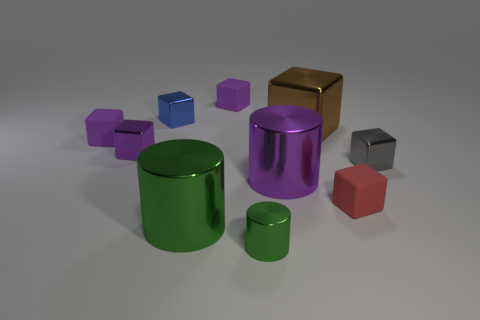Subtract all yellow spheres. How many purple blocks are left? 3 Subtract all tiny metallic cubes. How many cubes are left? 4 Subtract 2 cubes. How many cubes are left? 5 Subtract all brown blocks. How many blocks are left? 6 Subtract all green cubes. Subtract all green balls. How many cubes are left? 7 Subtract all blocks. How many objects are left? 3 Subtract all large purple objects. Subtract all large metallic cubes. How many objects are left? 8 Add 7 purple metal cylinders. How many purple metal cylinders are left? 8 Add 1 green things. How many green things exist? 3 Subtract 0 yellow cylinders. How many objects are left? 10 